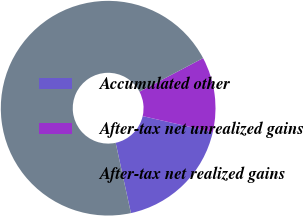<chart> <loc_0><loc_0><loc_500><loc_500><pie_chart><fcel>Accumulated other<fcel>After-tax net unrealized gains<fcel>After-tax net realized gains<nl><fcel>18.02%<fcel>11.31%<fcel>70.67%<nl></chart> 